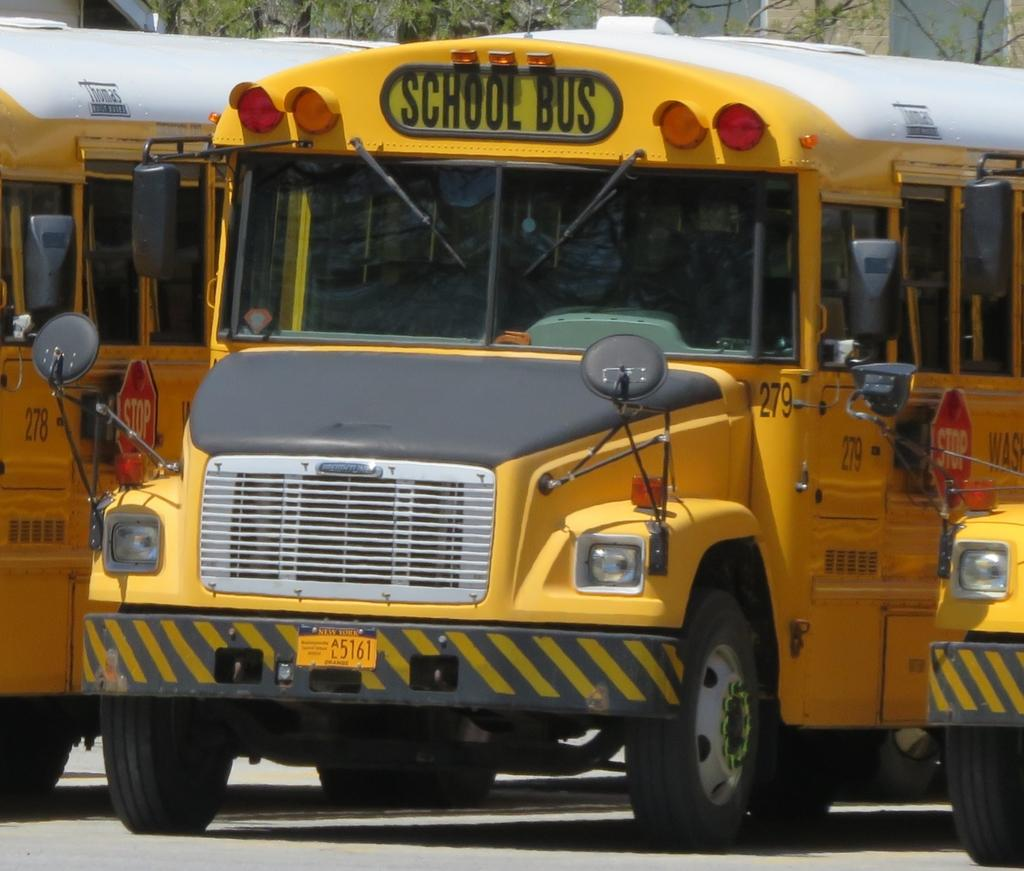What types of objects can be seen in the image? There are vehicles in the image. What can be seen at the top of the image? Trees, a wall, and windows are visible at the top of the image. What is visible at the bottom of the image? There is a road visible at the bottom of the image. What type of bells can be heard ringing in the image? There are no bells present in the image, and therefore no sound can be heard. 